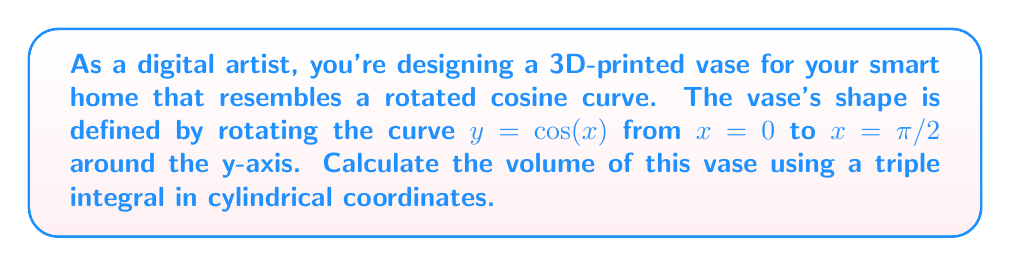Give your solution to this math problem. Let's approach this step-by-step:

1) In cylindrical coordinates, we have:
   $x = r \cos(\theta)$
   $y = y$
   $z = r \sin(\theta)$

2) The surface of the vase is defined by $r = \cos(y)$ when rotated around the y-axis.

3) The limits of integration are:
   $0 \leq \theta \leq 2\pi$ (full rotation)
   $0 \leq y \leq \pi/2$ (height of the vase)
   $0 \leq r \leq \cos(y)$ (radius at each height)

4) The volume formula in cylindrical coordinates is:
   $$V = \iiint r \, dr \, d\theta \, dy$$

5) Setting up the triple integral:
   $$V = \int_0^{\pi/2} \int_0^{2\pi} \int_0^{\cos(y)} r \, dr \, d\theta \, dy$$

6) Integrate with respect to r:
   $$V = \int_0^{\pi/2} \int_0^{2\pi} \left[\frac{r^2}{2}\right]_0^{\cos(y)} \, d\theta \, dy$$
   $$V = \int_0^{\pi/2} \int_0^{2\pi} \frac{\cos^2(y)}{2} \, d\theta \, dy$$

7) Integrate with respect to θ:
   $$V = \int_0^{\pi/2} \left[\frac{\cos^2(y)}{2} \theta\right]_0^{2\pi} \, dy$$
   $$V = \int_0^{\pi/2} \pi \cos^2(y) \, dy$$

8) To integrate $\cos^2(y)$, we can use the identity $\cos^2(y) = \frac{1 + \cos(2y)}{2}$:
   $$V = \pi \int_0^{\pi/2} \frac{1 + \cos(2y)}{2} \, dy$$
   $$V = \frac{\pi}{2} \int_0^{\pi/2} (1 + \cos(2y)) \, dy$$

9) Integrate:
   $$V = \frac{\pi}{2} \left[y + \frac{\sin(2y)}{2}\right]_0^{\pi/2}$$
   $$V = \frac{\pi}{2} \left(\frac{\pi}{2} + 0 - 0 - 0\right)$$
   $$V = \frac{\pi^2}{4}$$

Therefore, the volume of the vase is $\frac{\pi^2}{4}$ cubic units.
Answer: $\frac{\pi^2}{4}$ cubic units 